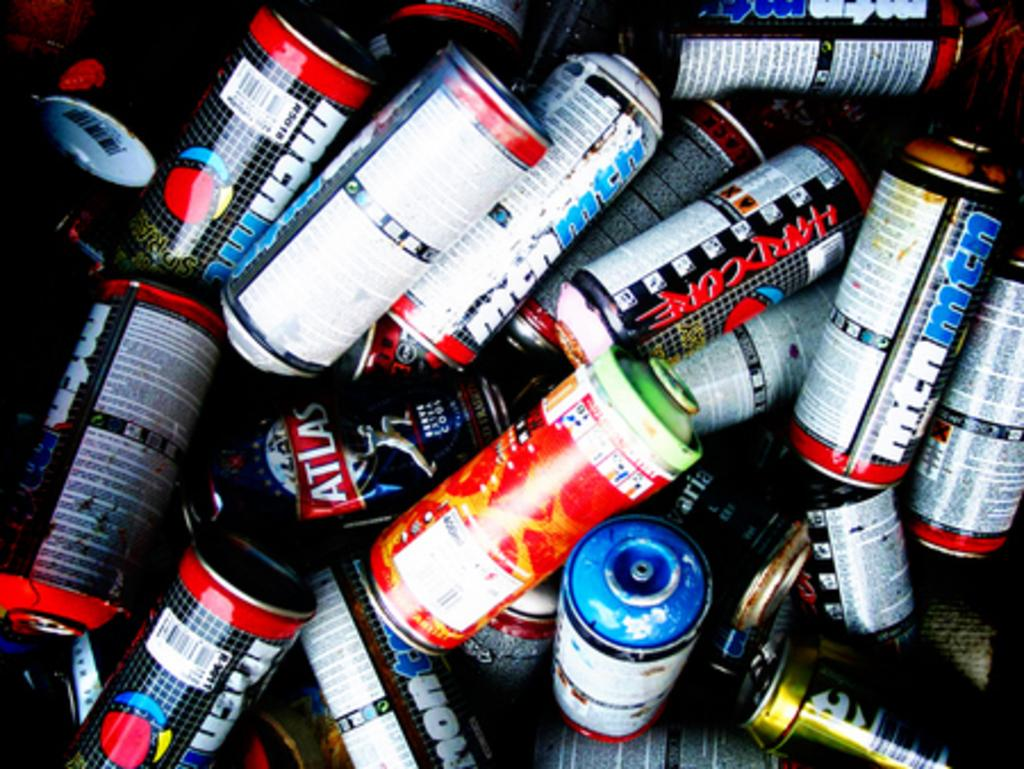<image>
Offer a succinct explanation of the picture presented. Many bottles of liquid including one that says "ATLAS" on it. 